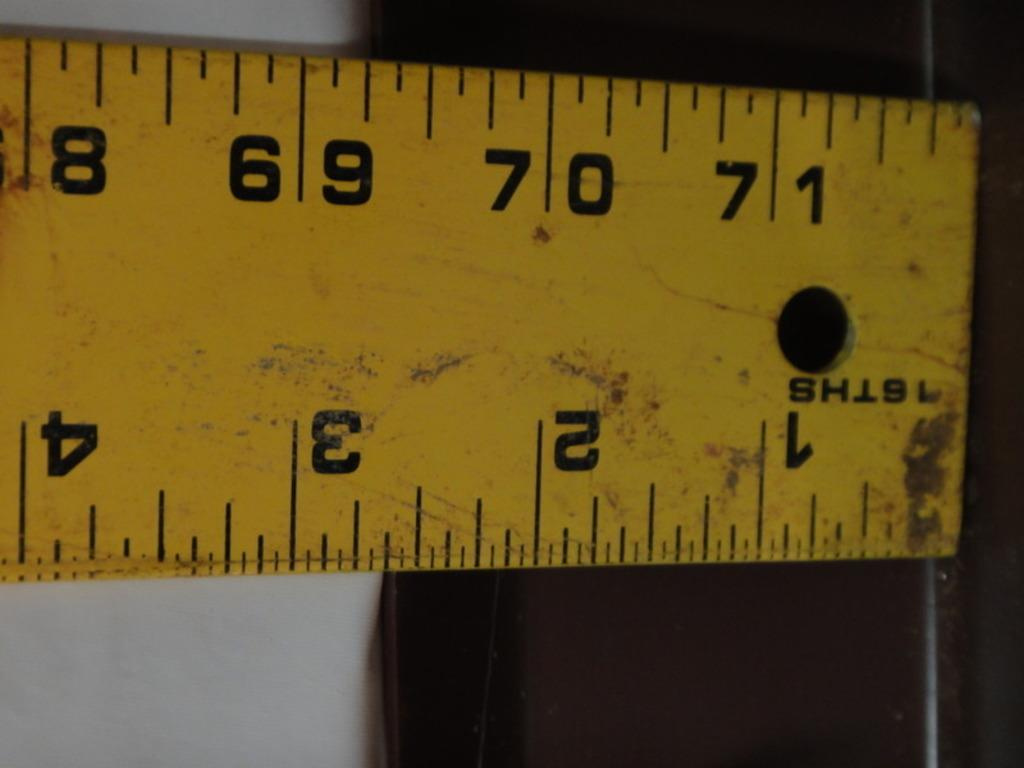<image>
Provide a brief description of the given image. A tape measure starts at 1/16th and goes all the way up to 71 1/2. 